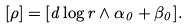<formula> <loc_0><loc_0><loc_500><loc_500>[ \rho ] = [ d \log r \wedge \alpha _ { 0 } + \beta _ { 0 } ] .</formula> 